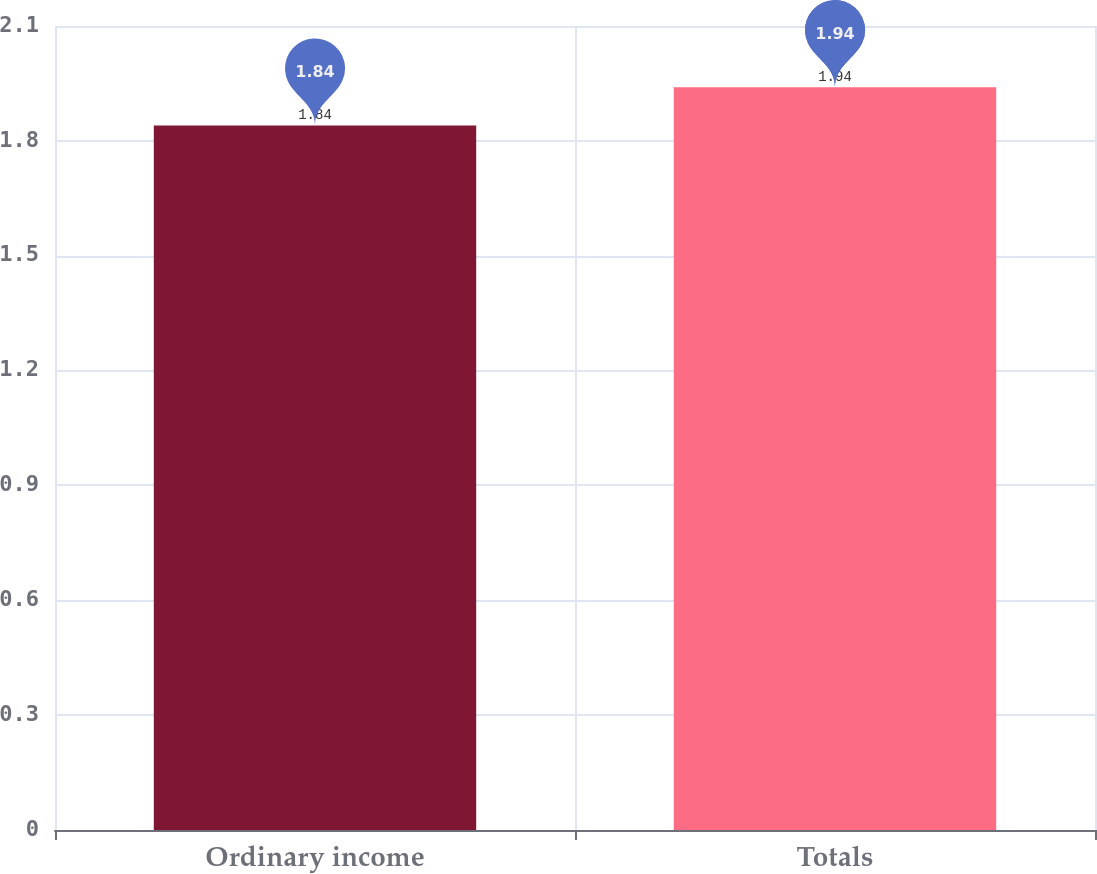Convert chart. <chart><loc_0><loc_0><loc_500><loc_500><bar_chart><fcel>Ordinary income<fcel>Totals<nl><fcel>1.84<fcel>1.94<nl></chart> 